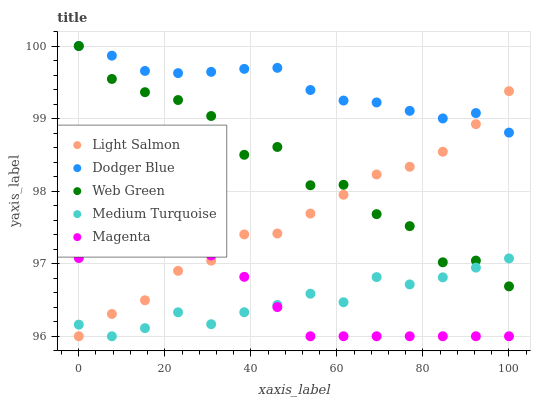Does Medium Turquoise have the minimum area under the curve?
Answer yes or no. Yes. Does Dodger Blue have the maximum area under the curve?
Answer yes or no. Yes. Does Light Salmon have the minimum area under the curve?
Answer yes or no. No. Does Light Salmon have the maximum area under the curve?
Answer yes or no. No. Is Magenta the smoothest?
Answer yes or no. Yes. Is Web Green the roughest?
Answer yes or no. Yes. Is Light Salmon the smoothest?
Answer yes or no. No. Is Light Salmon the roughest?
Answer yes or no. No. Does Magenta have the lowest value?
Answer yes or no. Yes. Does Dodger Blue have the lowest value?
Answer yes or no. No. Does Web Green have the highest value?
Answer yes or no. Yes. Does Light Salmon have the highest value?
Answer yes or no. No. Is Magenta less than Dodger Blue?
Answer yes or no. Yes. Is Dodger Blue greater than Magenta?
Answer yes or no. Yes. Does Medium Turquoise intersect Web Green?
Answer yes or no. Yes. Is Medium Turquoise less than Web Green?
Answer yes or no. No. Is Medium Turquoise greater than Web Green?
Answer yes or no. No. Does Magenta intersect Dodger Blue?
Answer yes or no. No. 